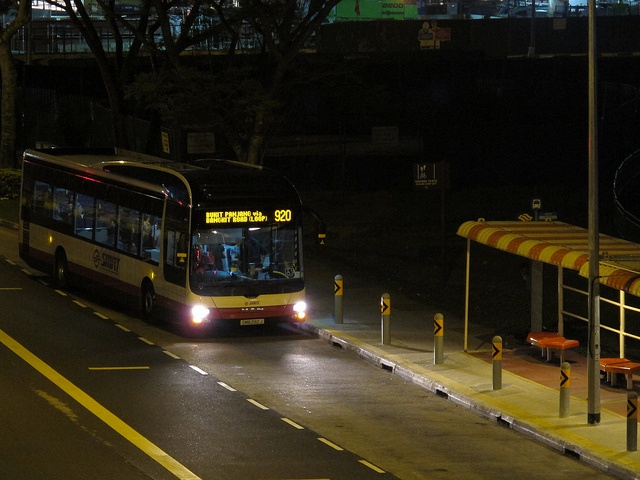Describe the objects in this image and their specific colors. I can see bus in black, maroon, olive, and gray tones, bench in black, maroon, and brown tones, bench in black, maroon, and brown tones, people in black, navy, gray, and purple tones, and people in black and purple tones in this image. 